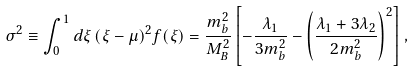Convert formula to latex. <formula><loc_0><loc_0><loc_500><loc_500>\sigma ^ { 2 } \equiv \int _ { 0 } ^ { 1 } d \xi \, ( \xi - \mu ) ^ { 2 } f ( \xi ) = \frac { m _ { b } ^ { 2 } } { M _ { B } ^ { 2 } } \left [ - \frac { \lambda _ { 1 } } { 3 m _ { b } ^ { 2 } } - \left ( \frac { \lambda _ { 1 } + 3 \lambda _ { 2 } } { 2 m _ { b } ^ { 2 } } \right ) ^ { 2 } \right ] ,</formula> 